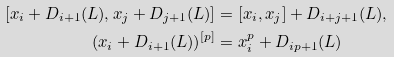Convert formula to latex. <formula><loc_0><loc_0><loc_500><loc_500>[ x _ { i } + D _ { i + 1 } ( L ) , x _ { j } + D _ { j + 1 } ( L ) ] & = [ x _ { i } , x _ { j } ] + D _ { i + j + 1 } ( L ) , \\ ( x _ { i } + D _ { i + 1 } ( L ) ) ^ { [ p ] } & = x _ { i } ^ { p } + D _ { i p + 1 } ( L )</formula> 